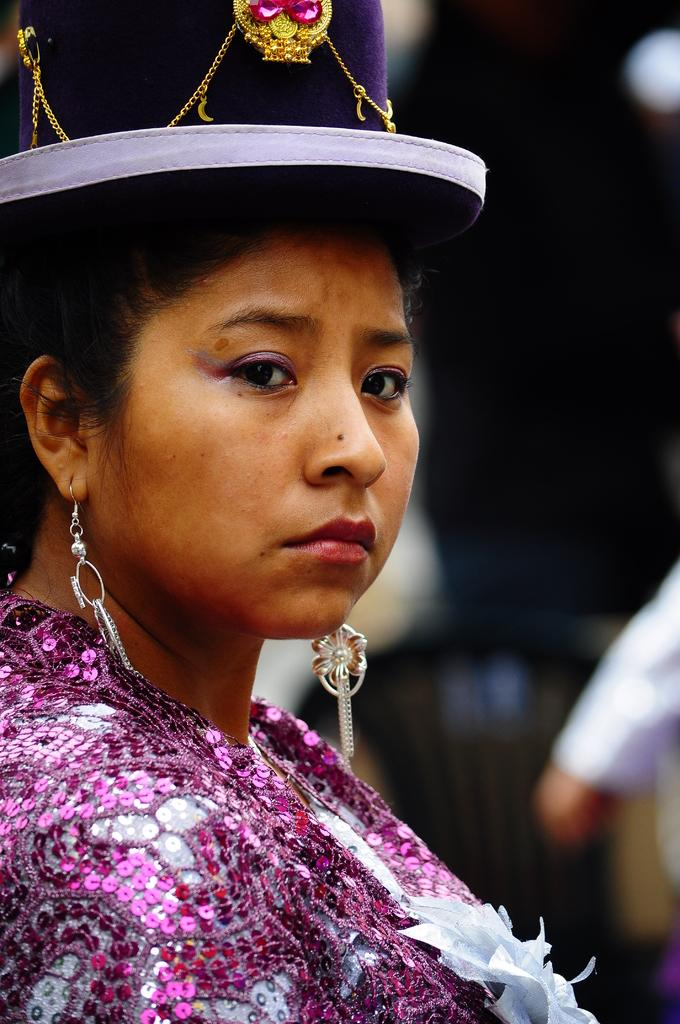What is present in the image? There is a woman in the image. Can you describe the object in the background of the image? The object in the background has a white and brown color. What type of liquid can be seen flowing from the woman's heart in the image? There is no liquid or heart visible in the image; it only features a woman and an object in the background. 